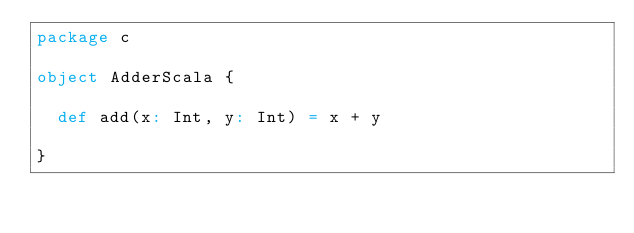<code> <loc_0><loc_0><loc_500><loc_500><_Scala_>package c

object AdderScala {

  def add(x: Int, y: Int) = x + y

}
</code> 